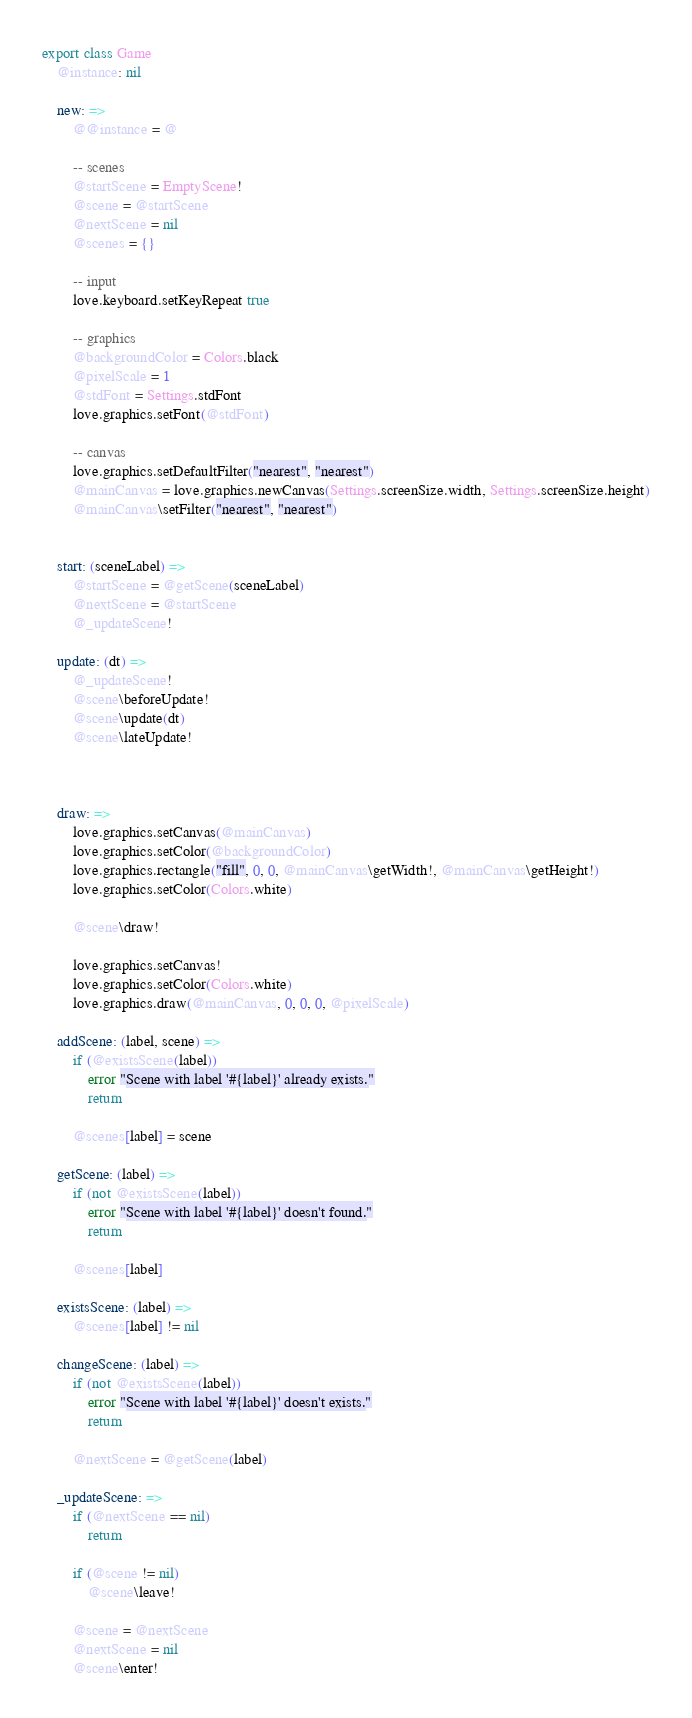<code> <loc_0><loc_0><loc_500><loc_500><_MoonScript_>export class Game
    @instance: nil

    new: =>
        @@instance = @

        -- scenes
        @startScene = EmptyScene!
        @scene = @startScene
        @nextScene = nil
        @scenes = {}

        -- input
        love.keyboard.setKeyRepeat true

        -- graphics
        @backgroundColor = Colors.black
        @pixelScale = 1
        @stdFont = Settings.stdFont
        love.graphics.setFont(@stdFont)

        -- canvas
        love.graphics.setDefaultFilter("nearest", "nearest")
        @mainCanvas = love.graphics.newCanvas(Settings.screenSize.width, Settings.screenSize.height)
        @mainCanvas\setFilter("nearest", "nearest")


    start: (sceneLabel) =>
        @startScene = @getScene(sceneLabel)
        @nextScene = @startScene
        @_updateScene!

    update: (dt) =>
        @_updateScene!
        @scene\beforeUpdate!
        @scene\update(dt)
        @scene\lateUpdate!



    draw: =>
        love.graphics.setCanvas(@mainCanvas)
        love.graphics.setColor(@backgroundColor)
        love.graphics.rectangle("fill", 0, 0, @mainCanvas\getWidth!, @mainCanvas\getHeight!)
        love.graphics.setColor(Colors.white)

        @scene\draw!

        love.graphics.setCanvas!
        love.graphics.setColor(Colors.white)
        love.graphics.draw(@mainCanvas, 0, 0, 0, @pixelScale)

    addScene: (label, scene) =>
        if (@existsScene(label))
            error "Scene with label '#{label}' already exists."
            return

        @scenes[label] = scene

    getScene: (label) =>
        if (not @existsScene(label))
            error "Scene with label '#{label}' doesn't found."
            return

        @scenes[label]

    existsScene: (label) =>
        @scenes[label] != nil

    changeScene: (label) =>
        if (not @existsScene(label))
            error "Scene with label '#{label}' doesn't exists."
            return

        @nextScene = @getScene(label)

    _updateScene: =>
        if (@nextScene == nil)
            return

        if (@scene != nil)
            @scene\leave!

        @scene = @nextScene
        @nextScene = nil
        @scene\enter!
</code> 